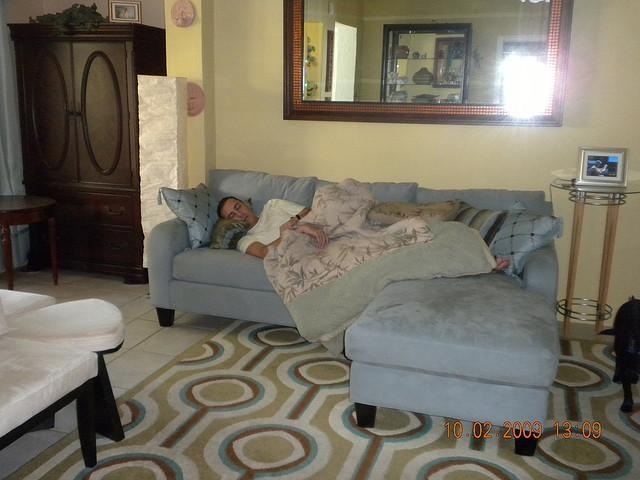How many beds are there?
Give a very brief answer. 1. 